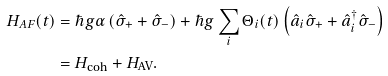Convert formula to latex. <formula><loc_0><loc_0><loc_500><loc_500>H _ { A F } ( t ) & = \hbar { g } \alpha \left ( \hat { \sigma } _ { + } + \hat { \sigma } _ { - } \right ) + \hbar { g } \sum _ { i } \Theta _ { i } ( t ) \left ( \hat { a } _ { i } \hat { \sigma } _ { + } + \hat { a } _ { i } ^ { \dag } \hat { \sigma } _ { - } \right ) \\ & = H _ { \text {coh} } + H _ { \text {AV} } .</formula> 